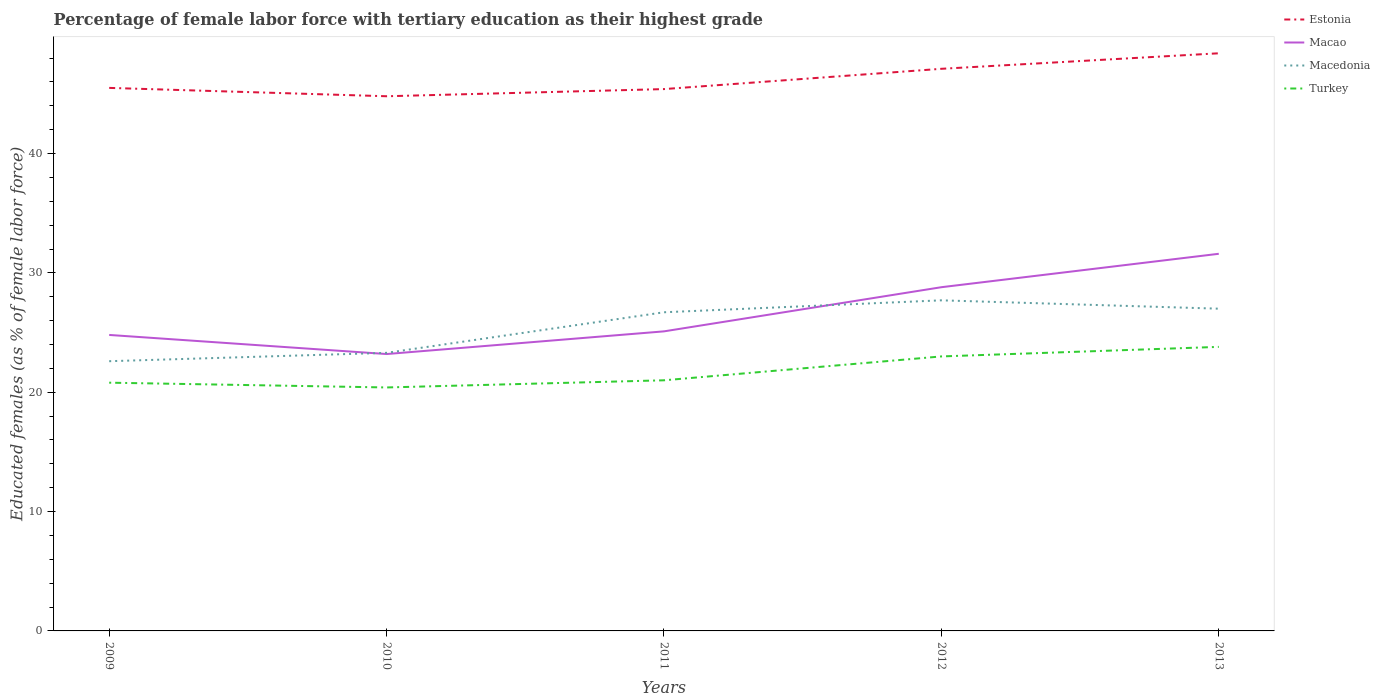Does the line corresponding to Macedonia intersect with the line corresponding to Turkey?
Provide a succinct answer. No. Is the number of lines equal to the number of legend labels?
Provide a succinct answer. Yes. Across all years, what is the maximum percentage of female labor force with tertiary education in Macao?
Offer a terse response. 23.2. In which year was the percentage of female labor force with tertiary education in Macao maximum?
Make the answer very short. 2010. What is the total percentage of female labor force with tertiary education in Macedonia in the graph?
Provide a succinct answer. -0.3. What is the difference between the highest and the second highest percentage of female labor force with tertiary education in Estonia?
Offer a very short reply. 3.6. Is the percentage of female labor force with tertiary education in Macao strictly greater than the percentage of female labor force with tertiary education in Turkey over the years?
Give a very brief answer. No. How many years are there in the graph?
Ensure brevity in your answer.  5. Are the values on the major ticks of Y-axis written in scientific E-notation?
Provide a succinct answer. No. What is the title of the graph?
Keep it short and to the point. Percentage of female labor force with tertiary education as their highest grade. Does "Belgium" appear as one of the legend labels in the graph?
Offer a very short reply. No. What is the label or title of the X-axis?
Your response must be concise. Years. What is the label or title of the Y-axis?
Give a very brief answer. Educated females (as % of female labor force). What is the Educated females (as % of female labor force) of Estonia in 2009?
Offer a very short reply. 45.5. What is the Educated females (as % of female labor force) in Macao in 2009?
Ensure brevity in your answer.  24.8. What is the Educated females (as % of female labor force) in Macedonia in 2009?
Your response must be concise. 22.6. What is the Educated females (as % of female labor force) of Turkey in 2009?
Your response must be concise. 20.8. What is the Educated females (as % of female labor force) of Estonia in 2010?
Offer a terse response. 44.8. What is the Educated females (as % of female labor force) of Macao in 2010?
Keep it short and to the point. 23.2. What is the Educated females (as % of female labor force) of Macedonia in 2010?
Keep it short and to the point. 23.3. What is the Educated females (as % of female labor force) in Turkey in 2010?
Keep it short and to the point. 20.4. What is the Educated females (as % of female labor force) in Estonia in 2011?
Make the answer very short. 45.4. What is the Educated females (as % of female labor force) of Macao in 2011?
Your answer should be compact. 25.1. What is the Educated females (as % of female labor force) of Macedonia in 2011?
Your answer should be compact. 26.7. What is the Educated females (as % of female labor force) in Turkey in 2011?
Provide a short and direct response. 21. What is the Educated females (as % of female labor force) of Estonia in 2012?
Your answer should be compact. 47.1. What is the Educated females (as % of female labor force) in Macao in 2012?
Make the answer very short. 28.8. What is the Educated females (as % of female labor force) of Macedonia in 2012?
Keep it short and to the point. 27.7. What is the Educated females (as % of female labor force) of Estonia in 2013?
Keep it short and to the point. 48.4. What is the Educated females (as % of female labor force) of Macao in 2013?
Keep it short and to the point. 31.6. What is the Educated females (as % of female labor force) in Turkey in 2013?
Your answer should be very brief. 23.8. Across all years, what is the maximum Educated females (as % of female labor force) in Estonia?
Ensure brevity in your answer.  48.4. Across all years, what is the maximum Educated females (as % of female labor force) of Macao?
Ensure brevity in your answer.  31.6. Across all years, what is the maximum Educated females (as % of female labor force) in Macedonia?
Make the answer very short. 27.7. Across all years, what is the maximum Educated females (as % of female labor force) in Turkey?
Offer a terse response. 23.8. Across all years, what is the minimum Educated females (as % of female labor force) of Estonia?
Provide a short and direct response. 44.8. Across all years, what is the minimum Educated females (as % of female labor force) of Macao?
Your answer should be very brief. 23.2. Across all years, what is the minimum Educated females (as % of female labor force) of Macedonia?
Provide a short and direct response. 22.6. Across all years, what is the minimum Educated females (as % of female labor force) in Turkey?
Make the answer very short. 20.4. What is the total Educated females (as % of female labor force) of Estonia in the graph?
Your answer should be compact. 231.2. What is the total Educated females (as % of female labor force) of Macao in the graph?
Provide a short and direct response. 133.5. What is the total Educated females (as % of female labor force) in Macedonia in the graph?
Make the answer very short. 127.3. What is the total Educated females (as % of female labor force) of Turkey in the graph?
Your answer should be compact. 109. What is the difference between the Educated females (as % of female labor force) of Estonia in 2009 and that in 2010?
Provide a short and direct response. 0.7. What is the difference between the Educated females (as % of female labor force) in Macao in 2009 and that in 2010?
Give a very brief answer. 1.6. What is the difference between the Educated females (as % of female labor force) of Macedonia in 2009 and that in 2010?
Ensure brevity in your answer.  -0.7. What is the difference between the Educated females (as % of female labor force) of Turkey in 2009 and that in 2010?
Provide a short and direct response. 0.4. What is the difference between the Educated females (as % of female labor force) in Estonia in 2009 and that in 2011?
Offer a terse response. 0.1. What is the difference between the Educated females (as % of female labor force) of Macedonia in 2009 and that in 2011?
Offer a very short reply. -4.1. What is the difference between the Educated females (as % of female labor force) in Turkey in 2009 and that in 2011?
Offer a very short reply. -0.2. What is the difference between the Educated females (as % of female labor force) of Estonia in 2009 and that in 2012?
Make the answer very short. -1.6. What is the difference between the Educated females (as % of female labor force) of Macao in 2009 and that in 2012?
Provide a short and direct response. -4. What is the difference between the Educated females (as % of female labor force) of Macedonia in 2009 and that in 2012?
Give a very brief answer. -5.1. What is the difference between the Educated females (as % of female labor force) of Turkey in 2009 and that in 2013?
Give a very brief answer. -3. What is the difference between the Educated females (as % of female labor force) of Turkey in 2010 and that in 2011?
Provide a short and direct response. -0.6. What is the difference between the Educated females (as % of female labor force) in Estonia in 2010 and that in 2012?
Your response must be concise. -2.3. What is the difference between the Educated females (as % of female labor force) in Macao in 2010 and that in 2012?
Provide a short and direct response. -5.6. What is the difference between the Educated females (as % of female labor force) of Macedonia in 2010 and that in 2012?
Provide a succinct answer. -4.4. What is the difference between the Educated females (as % of female labor force) in Turkey in 2010 and that in 2012?
Ensure brevity in your answer.  -2.6. What is the difference between the Educated females (as % of female labor force) in Macao in 2010 and that in 2013?
Offer a very short reply. -8.4. What is the difference between the Educated females (as % of female labor force) of Macedonia in 2010 and that in 2013?
Your response must be concise. -3.7. What is the difference between the Educated females (as % of female labor force) of Turkey in 2010 and that in 2013?
Your response must be concise. -3.4. What is the difference between the Educated females (as % of female labor force) of Estonia in 2011 and that in 2012?
Provide a short and direct response. -1.7. What is the difference between the Educated females (as % of female labor force) of Turkey in 2011 and that in 2012?
Your response must be concise. -2. What is the difference between the Educated females (as % of female labor force) of Estonia in 2011 and that in 2013?
Ensure brevity in your answer.  -3. What is the difference between the Educated females (as % of female labor force) in Macao in 2011 and that in 2013?
Your response must be concise. -6.5. What is the difference between the Educated females (as % of female labor force) in Macedonia in 2012 and that in 2013?
Offer a very short reply. 0.7. What is the difference between the Educated females (as % of female labor force) in Estonia in 2009 and the Educated females (as % of female labor force) in Macao in 2010?
Give a very brief answer. 22.3. What is the difference between the Educated females (as % of female labor force) in Estonia in 2009 and the Educated females (as % of female labor force) in Macedonia in 2010?
Give a very brief answer. 22.2. What is the difference between the Educated females (as % of female labor force) in Estonia in 2009 and the Educated females (as % of female labor force) in Turkey in 2010?
Keep it short and to the point. 25.1. What is the difference between the Educated females (as % of female labor force) in Macao in 2009 and the Educated females (as % of female labor force) in Macedonia in 2010?
Make the answer very short. 1.5. What is the difference between the Educated females (as % of female labor force) of Macao in 2009 and the Educated females (as % of female labor force) of Turkey in 2010?
Your answer should be compact. 4.4. What is the difference between the Educated females (as % of female labor force) of Estonia in 2009 and the Educated females (as % of female labor force) of Macao in 2011?
Provide a succinct answer. 20.4. What is the difference between the Educated females (as % of female labor force) of Estonia in 2009 and the Educated females (as % of female labor force) of Macedonia in 2011?
Make the answer very short. 18.8. What is the difference between the Educated females (as % of female labor force) in Macao in 2009 and the Educated females (as % of female labor force) in Macedonia in 2011?
Provide a short and direct response. -1.9. What is the difference between the Educated females (as % of female labor force) in Macao in 2009 and the Educated females (as % of female labor force) in Turkey in 2011?
Your response must be concise. 3.8. What is the difference between the Educated females (as % of female labor force) of Macedonia in 2009 and the Educated females (as % of female labor force) of Turkey in 2011?
Provide a short and direct response. 1.6. What is the difference between the Educated females (as % of female labor force) in Estonia in 2009 and the Educated females (as % of female labor force) in Macao in 2012?
Your answer should be compact. 16.7. What is the difference between the Educated females (as % of female labor force) in Estonia in 2009 and the Educated females (as % of female labor force) in Macedonia in 2012?
Offer a very short reply. 17.8. What is the difference between the Educated females (as % of female labor force) of Estonia in 2009 and the Educated females (as % of female labor force) of Turkey in 2012?
Provide a succinct answer. 22.5. What is the difference between the Educated females (as % of female labor force) of Macao in 2009 and the Educated females (as % of female labor force) of Turkey in 2012?
Make the answer very short. 1.8. What is the difference between the Educated females (as % of female labor force) in Macedonia in 2009 and the Educated females (as % of female labor force) in Turkey in 2012?
Provide a succinct answer. -0.4. What is the difference between the Educated females (as % of female labor force) in Estonia in 2009 and the Educated females (as % of female labor force) in Macao in 2013?
Your answer should be compact. 13.9. What is the difference between the Educated females (as % of female labor force) in Estonia in 2009 and the Educated females (as % of female labor force) in Macedonia in 2013?
Give a very brief answer. 18.5. What is the difference between the Educated females (as % of female labor force) of Estonia in 2009 and the Educated females (as % of female labor force) of Turkey in 2013?
Your answer should be very brief. 21.7. What is the difference between the Educated females (as % of female labor force) in Macedonia in 2009 and the Educated females (as % of female labor force) in Turkey in 2013?
Your answer should be very brief. -1.2. What is the difference between the Educated females (as % of female labor force) of Estonia in 2010 and the Educated females (as % of female labor force) of Macao in 2011?
Provide a succinct answer. 19.7. What is the difference between the Educated females (as % of female labor force) in Estonia in 2010 and the Educated females (as % of female labor force) in Macedonia in 2011?
Ensure brevity in your answer.  18.1. What is the difference between the Educated females (as % of female labor force) of Estonia in 2010 and the Educated females (as % of female labor force) of Turkey in 2011?
Offer a terse response. 23.8. What is the difference between the Educated females (as % of female labor force) of Macao in 2010 and the Educated females (as % of female labor force) of Turkey in 2011?
Ensure brevity in your answer.  2.2. What is the difference between the Educated females (as % of female labor force) of Estonia in 2010 and the Educated females (as % of female labor force) of Turkey in 2012?
Give a very brief answer. 21.8. What is the difference between the Educated females (as % of female labor force) in Macao in 2010 and the Educated females (as % of female labor force) in Macedonia in 2012?
Offer a terse response. -4.5. What is the difference between the Educated females (as % of female labor force) in Macao in 2010 and the Educated females (as % of female labor force) in Turkey in 2012?
Provide a succinct answer. 0.2. What is the difference between the Educated females (as % of female labor force) of Macedonia in 2010 and the Educated females (as % of female labor force) of Turkey in 2012?
Provide a short and direct response. 0.3. What is the difference between the Educated females (as % of female labor force) of Estonia in 2010 and the Educated females (as % of female labor force) of Macedonia in 2013?
Offer a very short reply. 17.8. What is the difference between the Educated females (as % of female labor force) of Estonia in 2011 and the Educated females (as % of female labor force) of Turkey in 2012?
Offer a very short reply. 22.4. What is the difference between the Educated females (as % of female labor force) in Estonia in 2011 and the Educated females (as % of female labor force) in Macao in 2013?
Your answer should be very brief. 13.8. What is the difference between the Educated females (as % of female labor force) of Estonia in 2011 and the Educated females (as % of female labor force) of Macedonia in 2013?
Provide a succinct answer. 18.4. What is the difference between the Educated females (as % of female labor force) in Estonia in 2011 and the Educated females (as % of female labor force) in Turkey in 2013?
Ensure brevity in your answer.  21.6. What is the difference between the Educated females (as % of female labor force) in Macao in 2011 and the Educated females (as % of female labor force) in Macedonia in 2013?
Offer a terse response. -1.9. What is the difference between the Educated females (as % of female labor force) in Macedonia in 2011 and the Educated females (as % of female labor force) in Turkey in 2013?
Keep it short and to the point. 2.9. What is the difference between the Educated females (as % of female labor force) in Estonia in 2012 and the Educated females (as % of female labor force) in Macao in 2013?
Your answer should be compact. 15.5. What is the difference between the Educated females (as % of female labor force) in Estonia in 2012 and the Educated females (as % of female labor force) in Macedonia in 2013?
Your response must be concise. 20.1. What is the difference between the Educated females (as % of female labor force) of Estonia in 2012 and the Educated females (as % of female labor force) of Turkey in 2013?
Keep it short and to the point. 23.3. What is the average Educated females (as % of female labor force) in Estonia per year?
Keep it short and to the point. 46.24. What is the average Educated females (as % of female labor force) in Macao per year?
Ensure brevity in your answer.  26.7. What is the average Educated females (as % of female labor force) of Macedonia per year?
Your answer should be compact. 25.46. What is the average Educated females (as % of female labor force) of Turkey per year?
Provide a succinct answer. 21.8. In the year 2009, what is the difference between the Educated females (as % of female labor force) in Estonia and Educated females (as % of female labor force) in Macao?
Provide a succinct answer. 20.7. In the year 2009, what is the difference between the Educated females (as % of female labor force) of Estonia and Educated females (as % of female labor force) of Macedonia?
Provide a short and direct response. 22.9. In the year 2009, what is the difference between the Educated females (as % of female labor force) of Estonia and Educated females (as % of female labor force) of Turkey?
Your answer should be compact. 24.7. In the year 2009, what is the difference between the Educated females (as % of female labor force) of Macao and Educated females (as % of female labor force) of Macedonia?
Provide a short and direct response. 2.2. In the year 2010, what is the difference between the Educated females (as % of female labor force) of Estonia and Educated females (as % of female labor force) of Macao?
Your answer should be very brief. 21.6. In the year 2010, what is the difference between the Educated females (as % of female labor force) in Estonia and Educated females (as % of female labor force) in Macedonia?
Provide a short and direct response. 21.5. In the year 2010, what is the difference between the Educated females (as % of female labor force) of Estonia and Educated females (as % of female labor force) of Turkey?
Provide a succinct answer. 24.4. In the year 2010, what is the difference between the Educated females (as % of female labor force) in Macao and Educated females (as % of female labor force) in Macedonia?
Your response must be concise. -0.1. In the year 2010, what is the difference between the Educated females (as % of female labor force) in Macao and Educated females (as % of female labor force) in Turkey?
Provide a short and direct response. 2.8. In the year 2011, what is the difference between the Educated females (as % of female labor force) in Estonia and Educated females (as % of female labor force) in Macao?
Make the answer very short. 20.3. In the year 2011, what is the difference between the Educated females (as % of female labor force) in Estonia and Educated females (as % of female labor force) in Turkey?
Offer a terse response. 24.4. In the year 2011, what is the difference between the Educated females (as % of female labor force) in Macao and Educated females (as % of female labor force) in Macedonia?
Your answer should be very brief. -1.6. In the year 2012, what is the difference between the Educated females (as % of female labor force) in Estonia and Educated females (as % of female labor force) in Macao?
Offer a very short reply. 18.3. In the year 2012, what is the difference between the Educated females (as % of female labor force) in Estonia and Educated females (as % of female labor force) in Turkey?
Your answer should be compact. 24.1. In the year 2012, what is the difference between the Educated females (as % of female labor force) in Macao and Educated females (as % of female labor force) in Macedonia?
Provide a short and direct response. 1.1. In the year 2012, what is the difference between the Educated females (as % of female labor force) of Macedonia and Educated females (as % of female labor force) of Turkey?
Provide a short and direct response. 4.7. In the year 2013, what is the difference between the Educated females (as % of female labor force) in Estonia and Educated females (as % of female labor force) in Macao?
Your response must be concise. 16.8. In the year 2013, what is the difference between the Educated females (as % of female labor force) in Estonia and Educated females (as % of female labor force) in Macedonia?
Provide a short and direct response. 21.4. In the year 2013, what is the difference between the Educated females (as % of female labor force) in Estonia and Educated females (as % of female labor force) in Turkey?
Ensure brevity in your answer.  24.6. In the year 2013, what is the difference between the Educated females (as % of female labor force) of Macao and Educated females (as % of female labor force) of Macedonia?
Offer a very short reply. 4.6. In the year 2013, what is the difference between the Educated females (as % of female labor force) in Macao and Educated females (as % of female labor force) in Turkey?
Give a very brief answer. 7.8. What is the ratio of the Educated females (as % of female labor force) of Estonia in 2009 to that in 2010?
Provide a succinct answer. 1.02. What is the ratio of the Educated females (as % of female labor force) of Macao in 2009 to that in 2010?
Provide a short and direct response. 1.07. What is the ratio of the Educated females (as % of female labor force) in Turkey in 2009 to that in 2010?
Provide a short and direct response. 1.02. What is the ratio of the Educated females (as % of female labor force) of Estonia in 2009 to that in 2011?
Keep it short and to the point. 1. What is the ratio of the Educated females (as % of female labor force) of Macao in 2009 to that in 2011?
Offer a very short reply. 0.99. What is the ratio of the Educated females (as % of female labor force) of Macedonia in 2009 to that in 2011?
Offer a very short reply. 0.85. What is the ratio of the Educated females (as % of female labor force) of Macao in 2009 to that in 2012?
Give a very brief answer. 0.86. What is the ratio of the Educated females (as % of female labor force) in Macedonia in 2009 to that in 2012?
Offer a terse response. 0.82. What is the ratio of the Educated females (as % of female labor force) in Turkey in 2009 to that in 2012?
Your answer should be compact. 0.9. What is the ratio of the Educated females (as % of female labor force) in Estonia in 2009 to that in 2013?
Your answer should be very brief. 0.94. What is the ratio of the Educated females (as % of female labor force) in Macao in 2009 to that in 2013?
Your answer should be compact. 0.78. What is the ratio of the Educated females (as % of female labor force) of Macedonia in 2009 to that in 2013?
Give a very brief answer. 0.84. What is the ratio of the Educated females (as % of female labor force) in Turkey in 2009 to that in 2013?
Ensure brevity in your answer.  0.87. What is the ratio of the Educated females (as % of female labor force) of Macao in 2010 to that in 2011?
Give a very brief answer. 0.92. What is the ratio of the Educated females (as % of female labor force) in Macedonia in 2010 to that in 2011?
Make the answer very short. 0.87. What is the ratio of the Educated females (as % of female labor force) of Turkey in 2010 to that in 2011?
Offer a terse response. 0.97. What is the ratio of the Educated females (as % of female labor force) of Estonia in 2010 to that in 2012?
Keep it short and to the point. 0.95. What is the ratio of the Educated females (as % of female labor force) in Macao in 2010 to that in 2012?
Keep it short and to the point. 0.81. What is the ratio of the Educated females (as % of female labor force) in Macedonia in 2010 to that in 2012?
Your answer should be very brief. 0.84. What is the ratio of the Educated females (as % of female labor force) of Turkey in 2010 to that in 2012?
Ensure brevity in your answer.  0.89. What is the ratio of the Educated females (as % of female labor force) of Estonia in 2010 to that in 2013?
Provide a short and direct response. 0.93. What is the ratio of the Educated females (as % of female labor force) in Macao in 2010 to that in 2013?
Provide a succinct answer. 0.73. What is the ratio of the Educated females (as % of female labor force) of Macedonia in 2010 to that in 2013?
Offer a very short reply. 0.86. What is the ratio of the Educated females (as % of female labor force) of Estonia in 2011 to that in 2012?
Provide a succinct answer. 0.96. What is the ratio of the Educated females (as % of female labor force) in Macao in 2011 to that in 2012?
Your answer should be compact. 0.87. What is the ratio of the Educated females (as % of female labor force) of Macedonia in 2011 to that in 2012?
Provide a succinct answer. 0.96. What is the ratio of the Educated females (as % of female labor force) in Estonia in 2011 to that in 2013?
Ensure brevity in your answer.  0.94. What is the ratio of the Educated females (as % of female labor force) in Macao in 2011 to that in 2013?
Your answer should be very brief. 0.79. What is the ratio of the Educated females (as % of female labor force) of Macedonia in 2011 to that in 2013?
Provide a succinct answer. 0.99. What is the ratio of the Educated females (as % of female labor force) of Turkey in 2011 to that in 2013?
Provide a short and direct response. 0.88. What is the ratio of the Educated females (as % of female labor force) in Estonia in 2012 to that in 2013?
Ensure brevity in your answer.  0.97. What is the ratio of the Educated females (as % of female labor force) of Macao in 2012 to that in 2013?
Your answer should be compact. 0.91. What is the ratio of the Educated females (as % of female labor force) in Macedonia in 2012 to that in 2013?
Keep it short and to the point. 1.03. What is the ratio of the Educated females (as % of female labor force) of Turkey in 2012 to that in 2013?
Offer a very short reply. 0.97. What is the difference between the highest and the second highest Educated females (as % of female labor force) of Estonia?
Offer a very short reply. 1.3. What is the difference between the highest and the second highest Educated females (as % of female labor force) in Macao?
Keep it short and to the point. 2.8. What is the difference between the highest and the second highest Educated females (as % of female labor force) in Turkey?
Provide a succinct answer. 0.8. What is the difference between the highest and the lowest Educated females (as % of female labor force) in Macao?
Your answer should be compact. 8.4. 